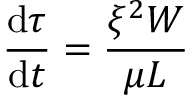<formula> <loc_0><loc_0><loc_500><loc_500>\frac { d \tau } { d t } = \frac { \xi ^ { 2 } W } { \mu L }</formula> 